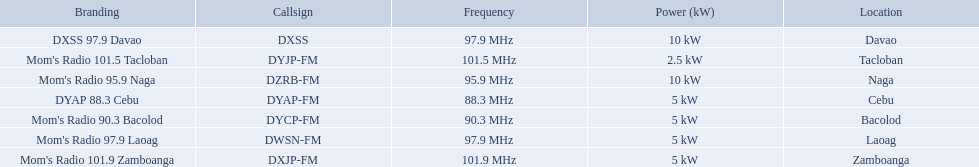Which stations broadcast in dyap-fm? Mom's Radio 97.9 Laoag, Mom's Radio 95.9 Naga, Mom's Radio 90.3 Bacolod, DYAP 88.3 Cebu, Mom's Radio 101.5 Tacloban, Mom's Radio 101.9 Zamboanga, DXSS 97.9 Davao. Of those stations which broadcast in dyap-fm, which stations broadcast with 5kw of power or under? Mom's Radio 97.9 Laoag, Mom's Radio 90.3 Bacolod, DYAP 88.3 Cebu, Mom's Radio 101.5 Tacloban, Mom's Radio 101.9 Zamboanga. Of those stations that broadcast with 5kw of power or under, which broadcasts with the least power? Mom's Radio 101.5 Tacloban. 